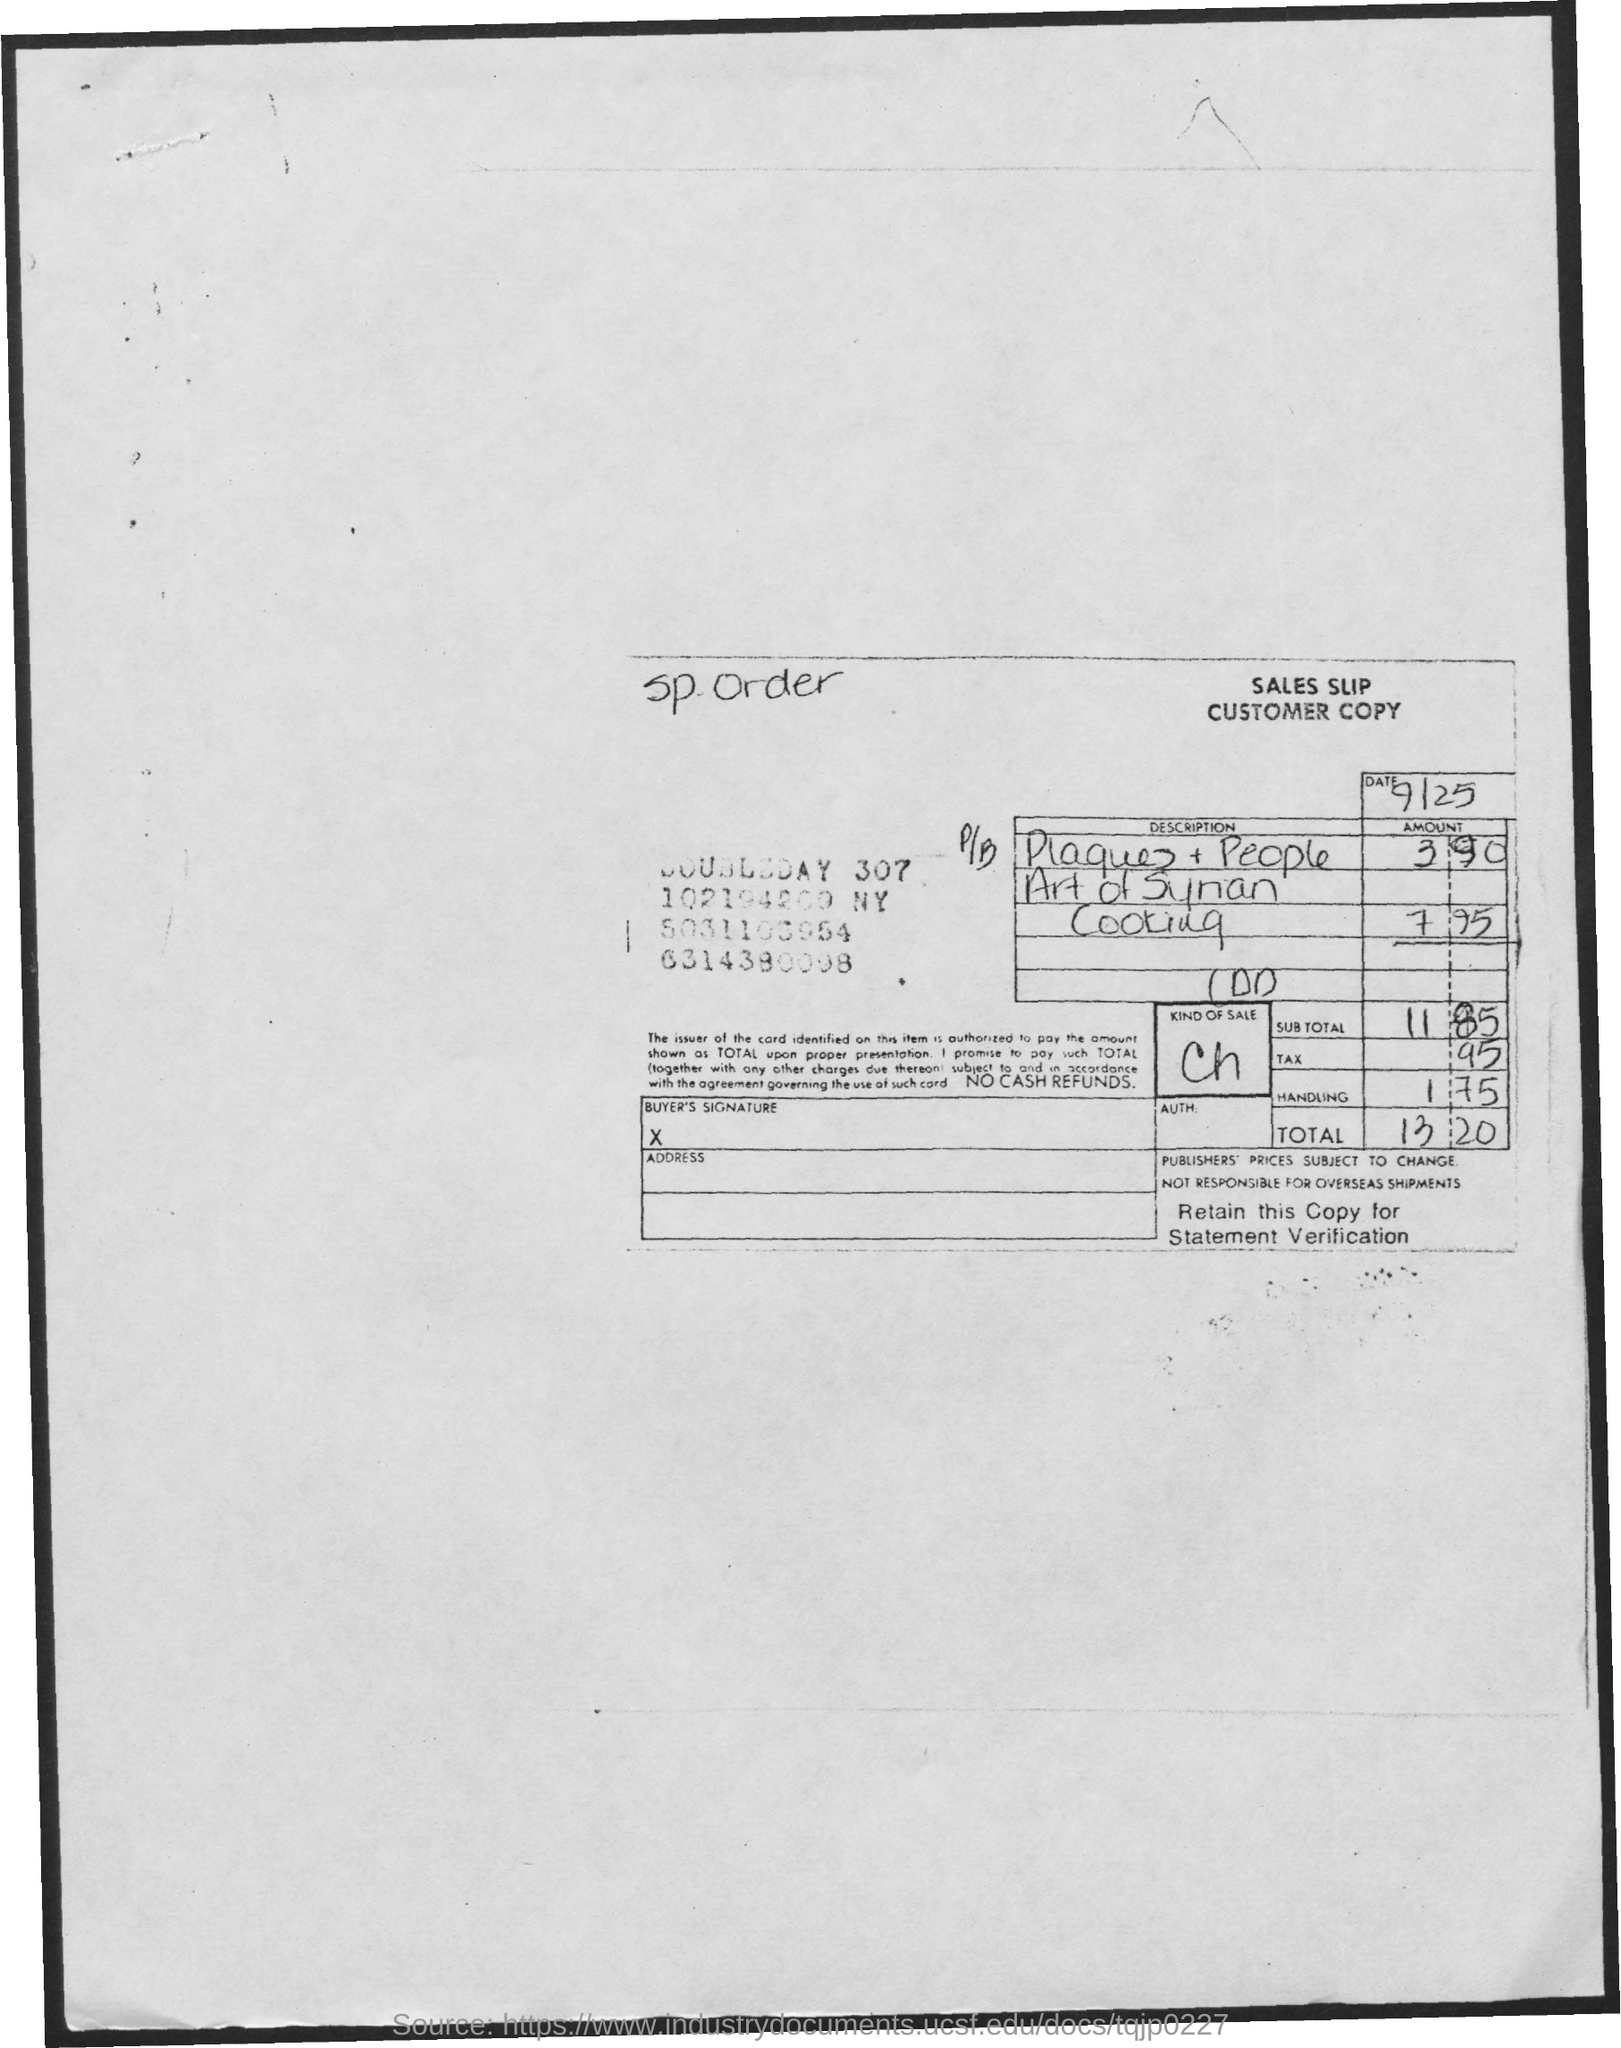What is the date mentioned in the sales slip?
Give a very brief answer. 9/25. What is the kind of sales given in the sales slip?
Your answer should be compact. Ch. 